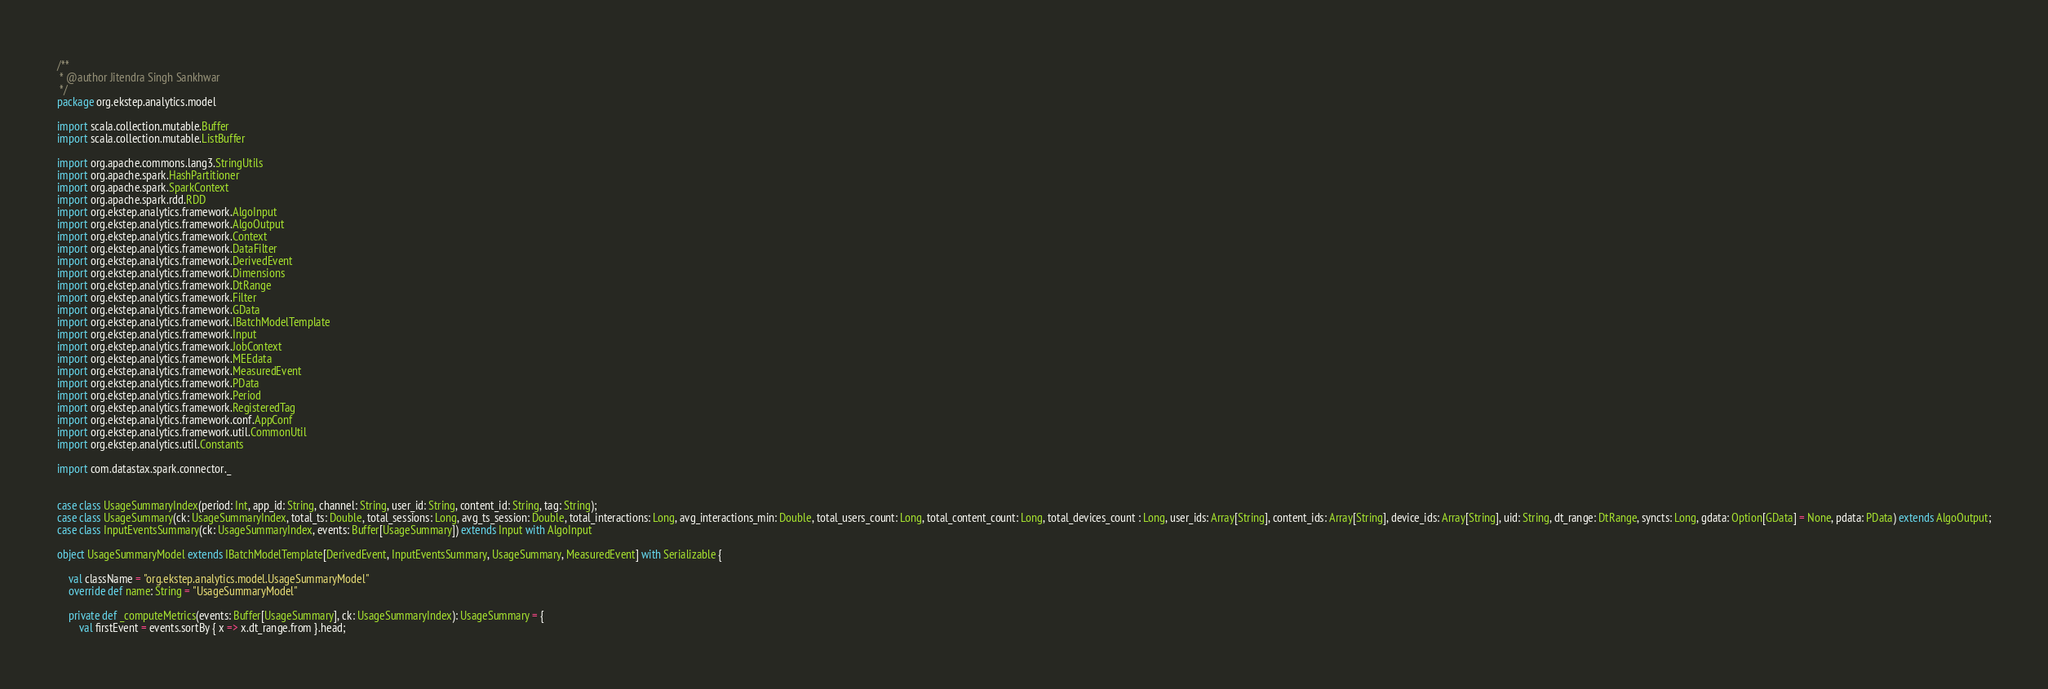Convert code to text. <code><loc_0><loc_0><loc_500><loc_500><_Scala_>/**
 * @author Jitendra Singh Sankhwar
 */
package org.ekstep.analytics.model

import scala.collection.mutable.Buffer
import scala.collection.mutable.ListBuffer

import org.apache.commons.lang3.StringUtils
import org.apache.spark.HashPartitioner
import org.apache.spark.SparkContext
import org.apache.spark.rdd.RDD
import org.ekstep.analytics.framework.AlgoInput
import org.ekstep.analytics.framework.AlgoOutput
import org.ekstep.analytics.framework.Context
import org.ekstep.analytics.framework.DataFilter
import org.ekstep.analytics.framework.DerivedEvent
import org.ekstep.analytics.framework.Dimensions
import org.ekstep.analytics.framework.DtRange
import org.ekstep.analytics.framework.Filter
import org.ekstep.analytics.framework.GData
import org.ekstep.analytics.framework.IBatchModelTemplate
import org.ekstep.analytics.framework.Input
import org.ekstep.analytics.framework.JobContext
import org.ekstep.analytics.framework.MEEdata
import org.ekstep.analytics.framework.MeasuredEvent
import org.ekstep.analytics.framework.PData
import org.ekstep.analytics.framework.Period
import org.ekstep.analytics.framework.RegisteredTag
import org.ekstep.analytics.framework.conf.AppConf
import org.ekstep.analytics.framework.util.CommonUtil
import org.ekstep.analytics.util.Constants

import com.datastax.spark.connector._


case class UsageSummaryIndex(period: Int, app_id: String, channel: String, user_id: String, content_id: String, tag: String);
case class UsageSummary(ck: UsageSummaryIndex, total_ts: Double, total_sessions: Long, avg_ts_session: Double, total_interactions: Long, avg_interactions_min: Double, total_users_count: Long, total_content_count: Long, total_devices_count : Long, user_ids: Array[String], content_ids: Array[String], device_ids: Array[String], uid: String, dt_range: DtRange, syncts: Long, gdata: Option[GData] = None, pdata: PData) extends AlgoOutput;
case class InputEventsSummary(ck: UsageSummaryIndex, events: Buffer[UsageSummary]) extends Input with AlgoInput

object UsageSummaryModel extends IBatchModelTemplate[DerivedEvent, InputEventsSummary, UsageSummary, MeasuredEvent] with Serializable {

    val className = "org.ekstep.analytics.model.UsageSummaryModel"
    override def name: String = "UsageSummaryModel"

    private def _computeMetrics(events: Buffer[UsageSummary], ck: UsageSummaryIndex): UsageSummary = {
        val firstEvent = events.sortBy { x => x.dt_range.from }.head;</code> 